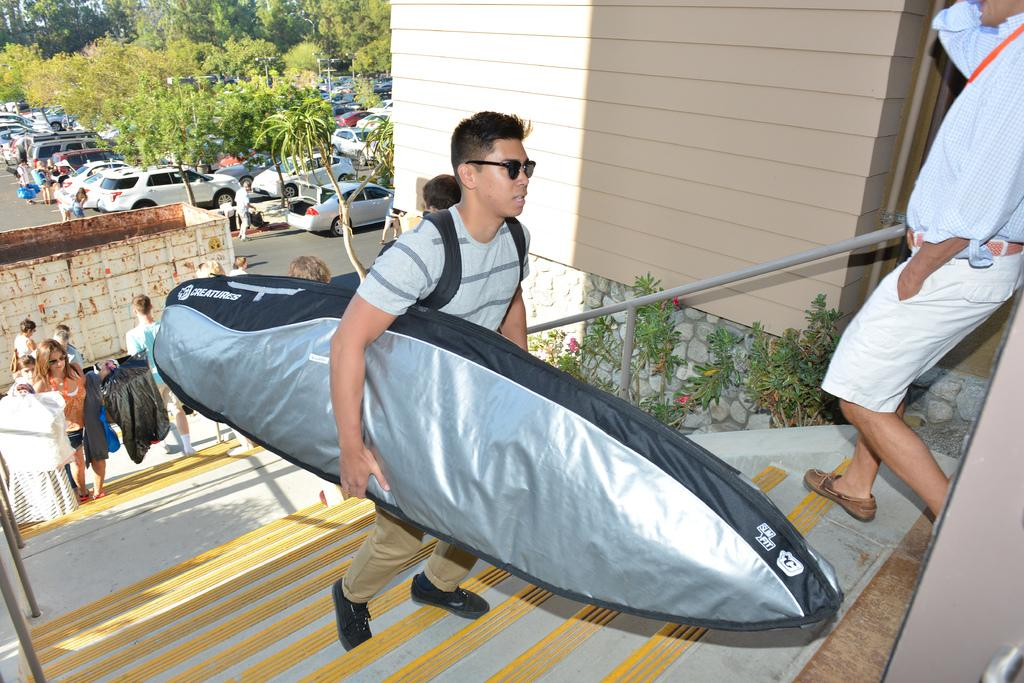What are the persons in the image doing? The persons in the image are walking. What are the persons holding while walking? The persons are holding objects. What can be seen in the background of the image? Trees and vehicles are visible in the background of the image. Are there any architectural features in the image? Yes, there is a wall and steps in the image. How many persons can be seen in the background? There are persons in the background. What type of soap is being used to clean the engine in the image? There is no soap or engine present in the image. How deep is the hole that the persons are walking around in the image? There is no hole present in the image. 